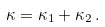<formula> <loc_0><loc_0><loc_500><loc_500>\kappa = \kappa _ { 1 } + \kappa _ { 2 } \, .</formula> 